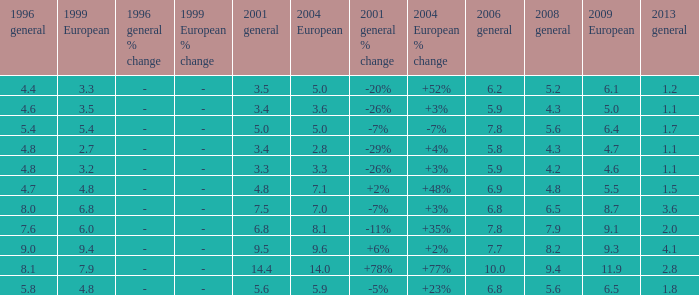How many values for 1999 European correspond to a value more than 4.7 in 2009 European, general 2001 more than 7.5, 2006 general at 10, and more than 9.4 in general 2008? 0.0. Can you parse all the data within this table? {'header': ['1996 general', '1999 European', '1996 general % change', '1999 European % change', '2001 general', '2004 European', '2001 general % change', '2004 European % change', '2006 general', '2008 general', '2009 European', '2013 general'], 'rows': [['4.4', '3.3', '-', '-', '3.5', '5.0', '-20%', '+52%', '6.2', '5.2', '6.1', '1.2'], ['4.6', '3.5', '-', '-', '3.4', '3.6', '-26%', '+3%', '5.9', '4.3', '5.0', '1.1'], ['5.4', '5.4', '-', '-', '5.0', '5.0', '-7%', '-7%', '7.8', '5.6', '6.4', '1.7'], ['4.8', '2.7', '-', '-', '3.4', '2.8', '-29%', '+4%', '5.8', '4.3', '4.7', '1.1'], ['4.8', '3.2', '-', '-', '3.3', '3.3', '-26%', '+3%', '5.9', '4.2', '4.6', '1.1'], ['4.7', '4.8', '-', '-', '4.8', '7.1', '+2%', '+48%', '6.9', '4.8', '5.5', '1.5'], ['8.0', '6.8', '-', '-', '7.5', '7.0', '-7%', '+3%', '6.8', '6.5', '8.7', '3.6'], ['7.6', '6.0', '-', '-', '6.8', '8.1', '-11%', '+35%', '7.8', '7.9', '9.1', '2.0'], ['9.0', '9.4', '-', '-', '9.5', '9.6', '+6%', '+2%', '7.7', '8.2', '9.3', '4.1'], ['8.1', '7.9', '-', '-', '14.4', '14.0', '+78%', '+77%', '10.0', '9.4', '11.9', '2.8'], ['5.8', '4.8', '-', '-', '5.6', '5.9', '-5%', '+23%', '6.8', '5.6', '6.5', '1.8']]} 